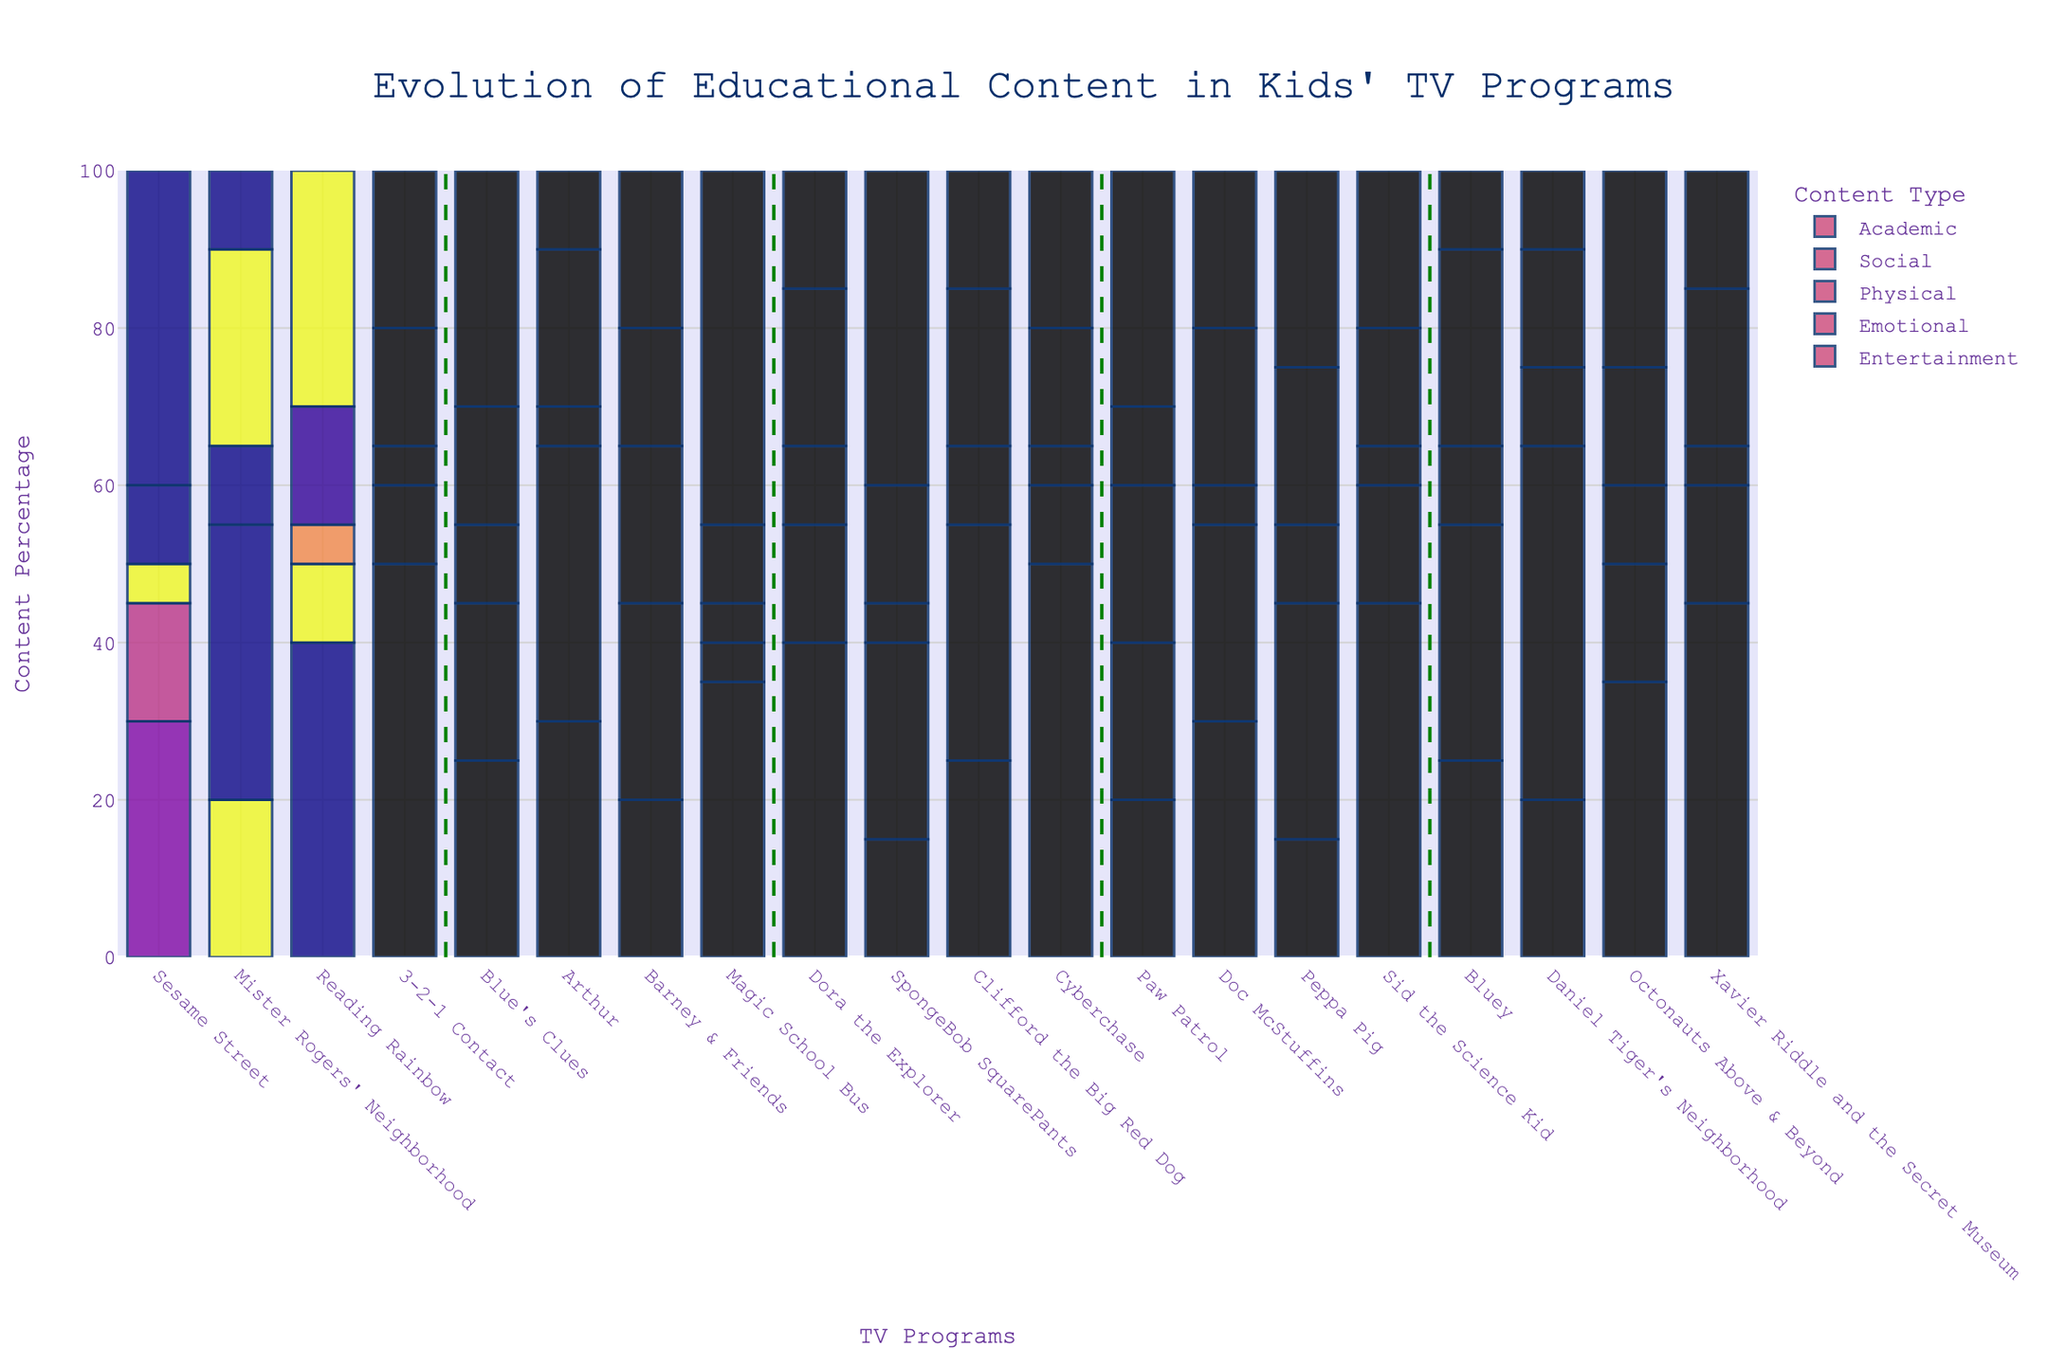Which decade had the highest percentage of social content in a single program? Look for the decade and program combination with the highest bar segment for the social category.
Answer: 2020s, Daniel Tiger's Neighborhood Which program had the least percentage of entertainment content in the 2000s? Identify the smallest green bar segment among the 2000s programs.
Answer: Clifford the Big Red Dog and Dora the Explorer Between "Peppa Pig" and "Arthur," which program has more emotional content? Compare the height of the emotional content segments (illustrated typically by a specific color) for both programs.
Answer: Peppa Pig What's the total percentage of physical content in both the 1980s and 1990s? Sum the percentages of physical content for all listed programs in the 1980s and 1990s.
Answer: 100% Compare "Magic School Bus" and "Cyberchase" regarding academic content. Which has more? Identify the height of the academic content segments for both programs and compare.
Answer: Cyberchase Across the decades, which program has the highest percentage of entertainment content? Identify the program with the largest green (entertainment) bar segment.
Answer: Magic School Bus Which decade shows the first introduction of a program with substantial physical content (around 20%)? Look for the first decade where a program has a significant physical content segment (roughly 20%).
Answer: 1990s with "Barney & Friends" Between "Doc McStuffins" and "Xavier Riddle and the Secret Museum," which one has more social content? Compare the heights of the social content segments for both programs.
Answer: Doc McStuffins What is the average percentage of academic content in the 2020s programs? Sum the academic percentages of all 2020s programs and divide by the number of programs in that decade.
Answer: 31.25% Which program in the 2010s had the highest percentage of emotional content? Compare the heights of the emotional content segments for all listed programs in the 2010s.
Answer: Doc McStuffins 